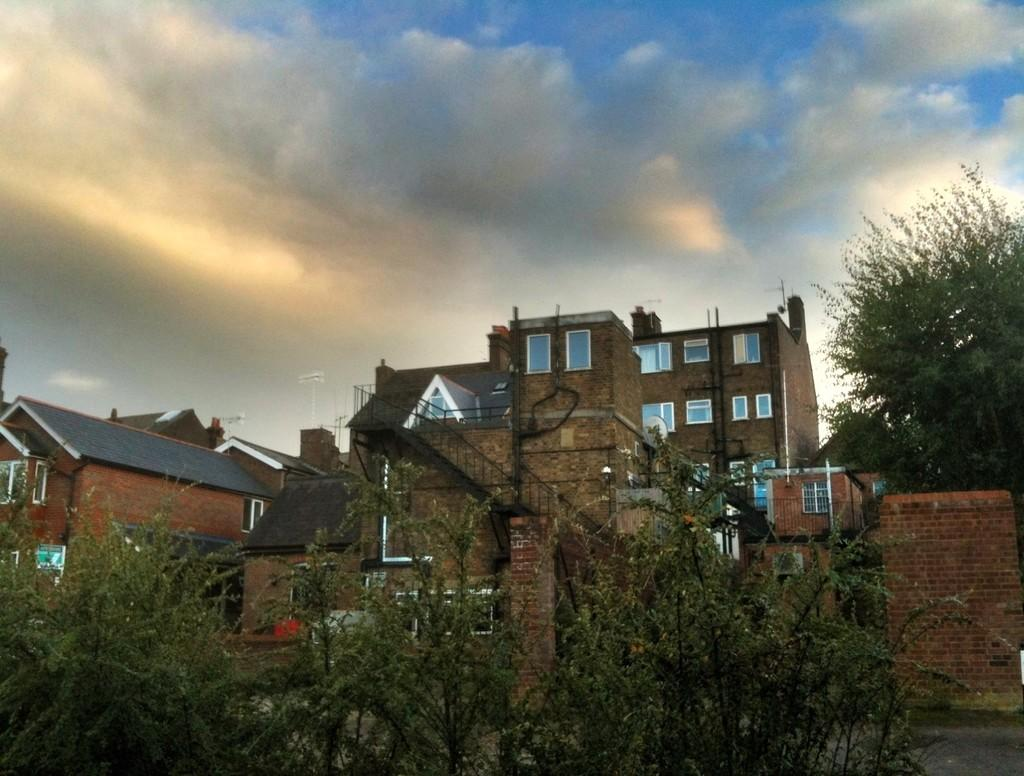What type of structures can be seen in the image? There are many buildings in the image. What type of vegetation is visible at the bottom of the image? Plants are visible at the bottom of the image. Where is the gate located in the image? The gate is on the right side of the image. What type of wall is present on the right side of the image? A brick wall is present on the right side of the image. What is visible at the top of the image? The sky is visible at the top of the image. What can be seen in the sky? Clouds are present in the sky. What type of song can be heard playing in the background of the image? There is no sound or music present in the image, so it is not possible to determine what song might be heard. 